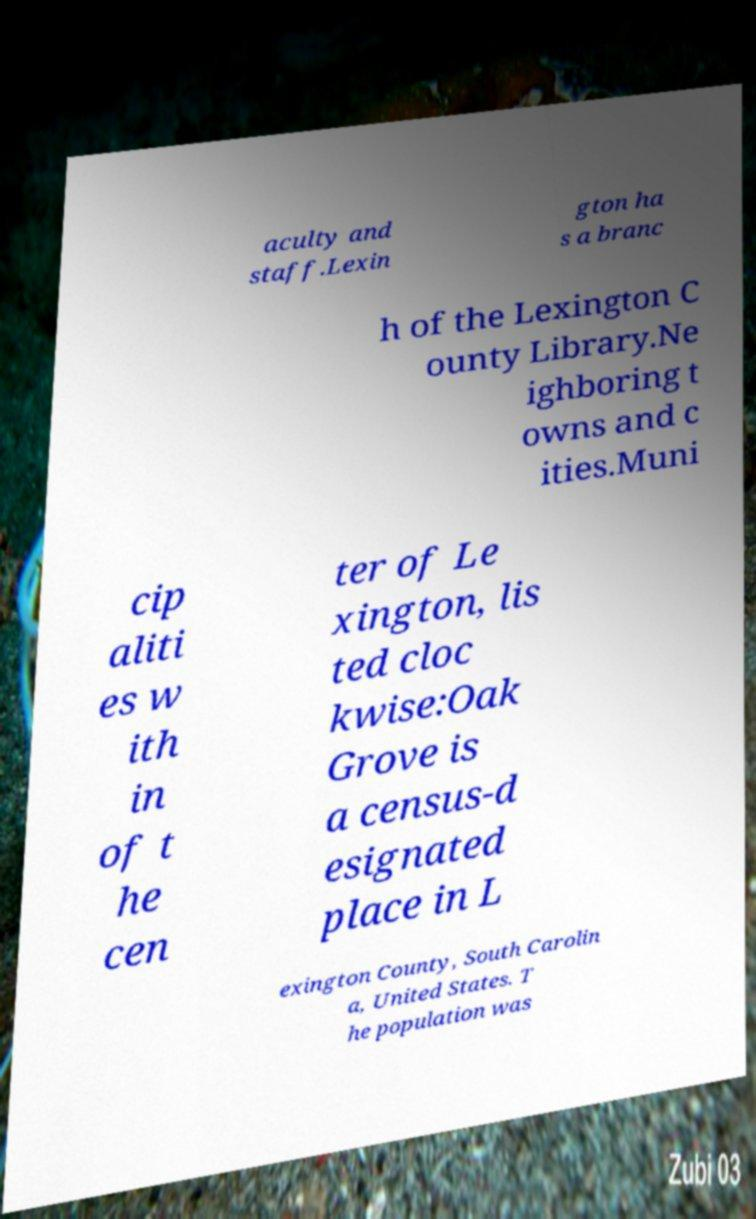What messages or text are displayed in this image? I need them in a readable, typed format. aculty and staff.Lexin gton ha s a branc h of the Lexington C ounty Library.Ne ighboring t owns and c ities.Muni cip aliti es w ith in of t he cen ter of Le xington, lis ted cloc kwise:Oak Grove is a census-d esignated place in L exington County, South Carolin a, United States. T he population was 